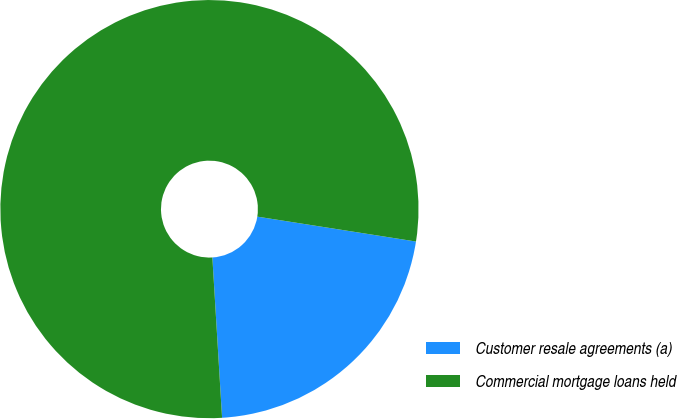Convert chart to OTSL. <chart><loc_0><loc_0><loc_500><loc_500><pie_chart><fcel>Customer resale agreements (a)<fcel>Commercial mortgage loans held<nl><fcel>21.56%<fcel>78.44%<nl></chart> 